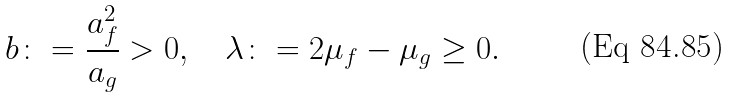Convert formula to latex. <formula><loc_0><loc_0><loc_500><loc_500>b \colon = \frac { a ^ { 2 } _ { f } } { a _ { g } } > 0 , \quad \lambda \colon = 2 \mu _ { f } - \mu _ { g } \geq 0 .</formula> 